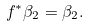Convert formula to latex. <formula><loc_0><loc_0><loc_500><loc_500>f ^ { * } \beta _ { 2 } = \beta _ { 2 } .</formula> 